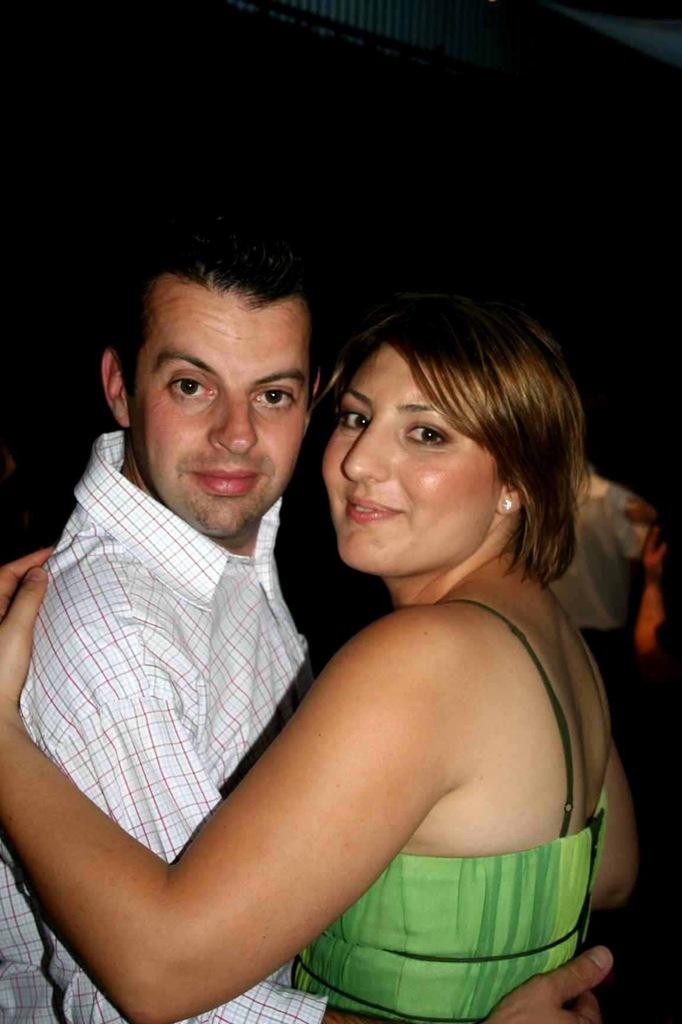How many people are in the image? There are two people in the middle of the image, a man and a woman. What are the man and woman doing in the image? The man and woman are holding each other. Can you describe the background of the image? There is a person visible in the background of the image, and there is a black color object or area in the background. What is the title of the book the tiger is reading in the image? There is no book or tiger present in the image. 